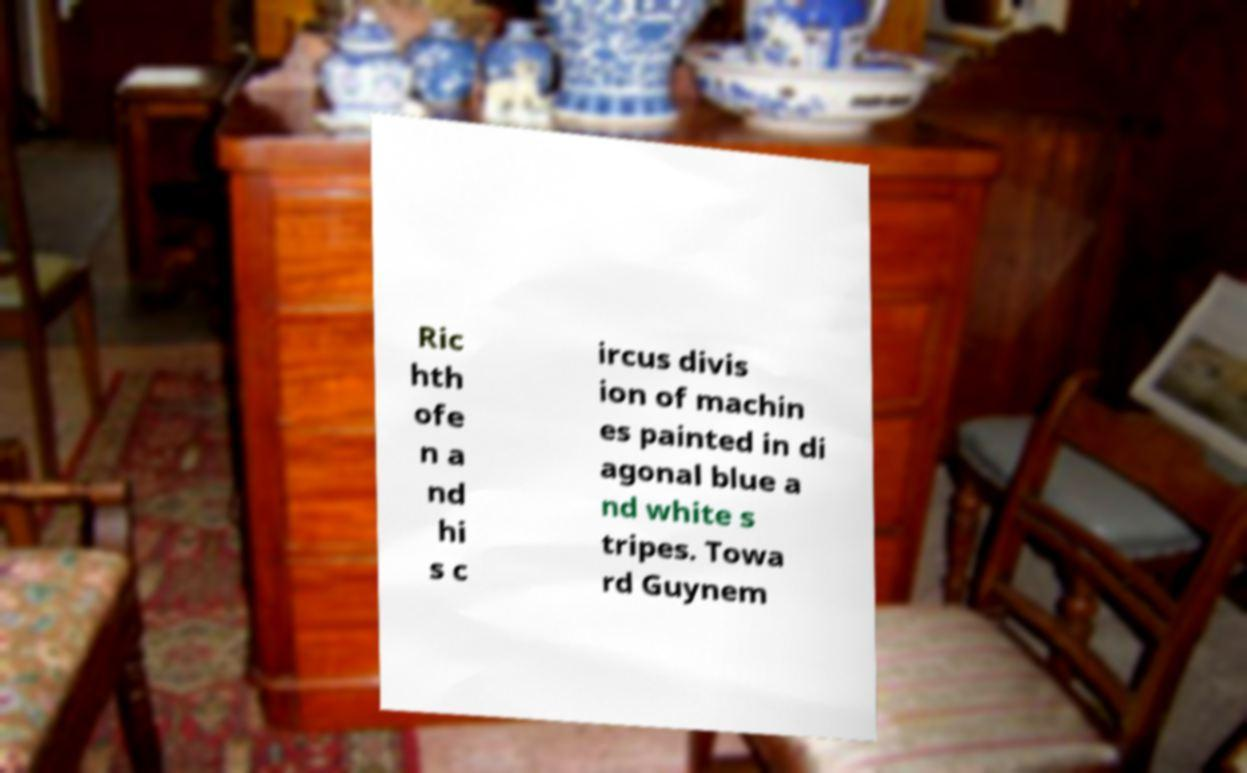I need the written content from this picture converted into text. Can you do that? Ric hth ofe n a nd hi s c ircus divis ion of machin es painted in di agonal blue a nd white s tripes. Towa rd Guynem 